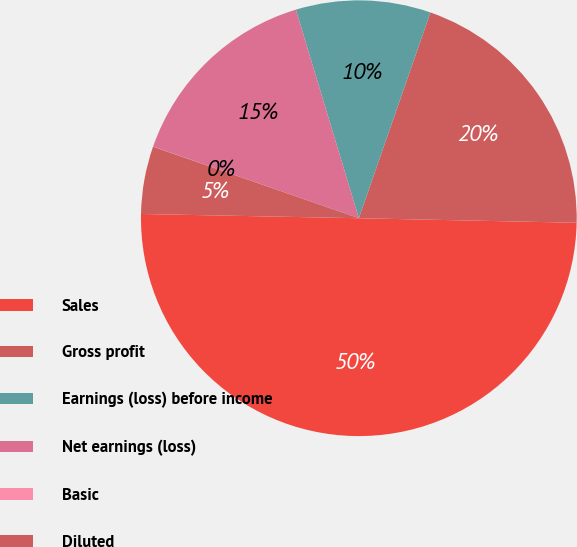Convert chart to OTSL. <chart><loc_0><loc_0><loc_500><loc_500><pie_chart><fcel>Sales<fcel>Gross profit<fcel>Earnings (loss) before income<fcel>Net earnings (loss)<fcel>Basic<fcel>Diluted<nl><fcel>49.98%<fcel>20.0%<fcel>10.0%<fcel>15.0%<fcel>0.01%<fcel>5.01%<nl></chart> 